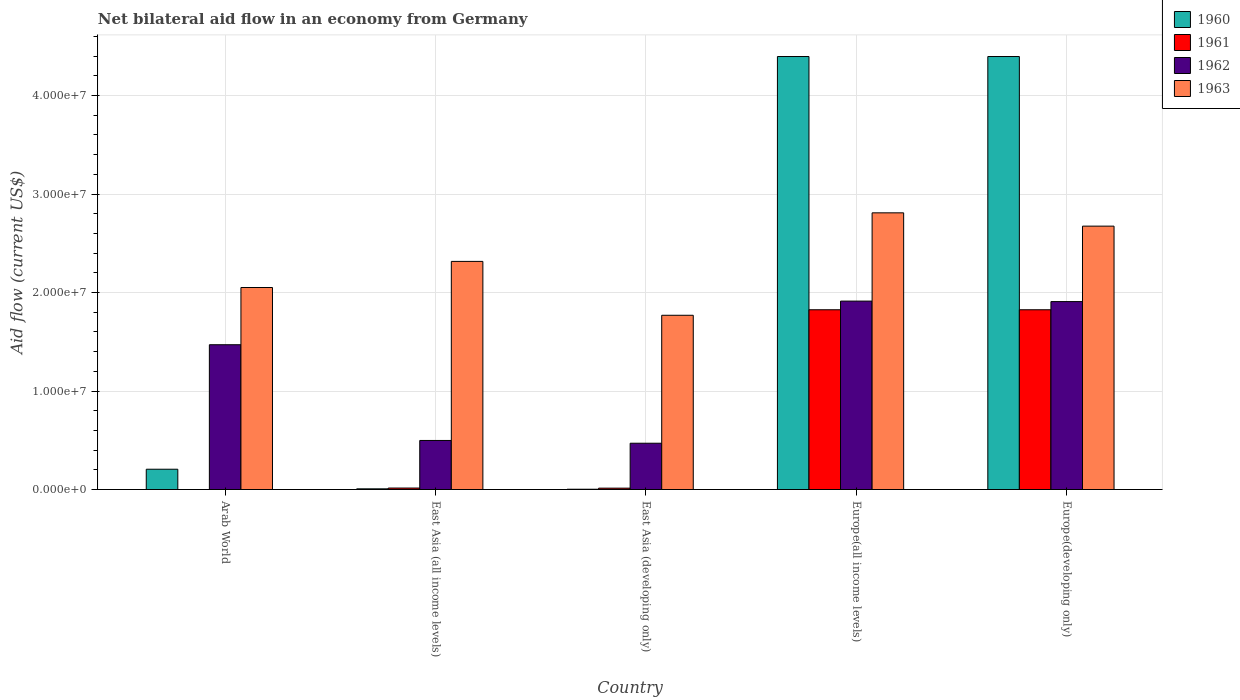Are the number of bars per tick equal to the number of legend labels?
Give a very brief answer. No. How many bars are there on the 3rd tick from the left?
Offer a terse response. 4. What is the label of the 1st group of bars from the left?
Keep it short and to the point. Arab World. In how many cases, is the number of bars for a given country not equal to the number of legend labels?
Your response must be concise. 1. What is the net bilateral aid flow in 1961 in Europe(developing only)?
Provide a succinct answer. 1.82e+07. Across all countries, what is the maximum net bilateral aid flow in 1960?
Your response must be concise. 4.40e+07. In which country was the net bilateral aid flow in 1960 maximum?
Ensure brevity in your answer.  Europe(all income levels). What is the total net bilateral aid flow in 1960 in the graph?
Your answer should be compact. 9.01e+07. What is the difference between the net bilateral aid flow in 1962 in East Asia (all income levels) and that in Europe(developing only)?
Make the answer very short. -1.41e+07. What is the difference between the net bilateral aid flow in 1963 in Arab World and the net bilateral aid flow in 1960 in Europe(all income levels)?
Your answer should be compact. -2.34e+07. What is the average net bilateral aid flow in 1960 per country?
Keep it short and to the point. 1.80e+07. What is the difference between the net bilateral aid flow of/in 1963 and net bilateral aid flow of/in 1962 in Europe(developing only)?
Make the answer very short. 7.66e+06. In how many countries, is the net bilateral aid flow in 1960 greater than 32000000 US$?
Give a very brief answer. 2. What is the ratio of the net bilateral aid flow in 1960 in Arab World to that in East Asia (developing only)?
Provide a short and direct response. 68.67. Is the net bilateral aid flow in 1960 in East Asia (developing only) less than that in Europe(developing only)?
Provide a succinct answer. Yes. What is the difference between the highest and the second highest net bilateral aid flow in 1960?
Offer a very short reply. 4.19e+07. What is the difference between the highest and the lowest net bilateral aid flow in 1962?
Provide a short and direct response. 1.44e+07. Is the sum of the net bilateral aid flow in 1960 in East Asia (developing only) and Europe(developing only) greater than the maximum net bilateral aid flow in 1961 across all countries?
Ensure brevity in your answer.  Yes. Is it the case that in every country, the sum of the net bilateral aid flow in 1962 and net bilateral aid flow in 1963 is greater than the sum of net bilateral aid flow in 1961 and net bilateral aid flow in 1960?
Your answer should be compact. No. How many bars are there?
Make the answer very short. 19. Are all the bars in the graph horizontal?
Give a very brief answer. No. Does the graph contain grids?
Ensure brevity in your answer.  Yes. How many legend labels are there?
Your answer should be compact. 4. How are the legend labels stacked?
Ensure brevity in your answer.  Vertical. What is the title of the graph?
Your answer should be compact. Net bilateral aid flow in an economy from Germany. What is the Aid flow (current US$) of 1960 in Arab World?
Keep it short and to the point. 2.06e+06. What is the Aid flow (current US$) of 1962 in Arab World?
Offer a very short reply. 1.47e+07. What is the Aid flow (current US$) of 1963 in Arab World?
Your answer should be very brief. 2.05e+07. What is the Aid flow (current US$) of 1961 in East Asia (all income levels)?
Ensure brevity in your answer.  1.50e+05. What is the Aid flow (current US$) in 1962 in East Asia (all income levels)?
Offer a terse response. 4.98e+06. What is the Aid flow (current US$) in 1963 in East Asia (all income levels)?
Offer a terse response. 2.32e+07. What is the Aid flow (current US$) of 1961 in East Asia (developing only)?
Provide a short and direct response. 1.40e+05. What is the Aid flow (current US$) of 1962 in East Asia (developing only)?
Your response must be concise. 4.70e+06. What is the Aid flow (current US$) in 1963 in East Asia (developing only)?
Provide a short and direct response. 1.77e+07. What is the Aid flow (current US$) of 1960 in Europe(all income levels)?
Your response must be concise. 4.40e+07. What is the Aid flow (current US$) of 1961 in Europe(all income levels)?
Ensure brevity in your answer.  1.82e+07. What is the Aid flow (current US$) in 1962 in Europe(all income levels)?
Give a very brief answer. 1.91e+07. What is the Aid flow (current US$) in 1963 in Europe(all income levels)?
Give a very brief answer. 2.81e+07. What is the Aid flow (current US$) of 1960 in Europe(developing only)?
Offer a very short reply. 4.40e+07. What is the Aid flow (current US$) in 1961 in Europe(developing only)?
Provide a short and direct response. 1.82e+07. What is the Aid flow (current US$) of 1962 in Europe(developing only)?
Your response must be concise. 1.91e+07. What is the Aid flow (current US$) of 1963 in Europe(developing only)?
Provide a short and direct response. 2.67e+07. Across all countries, what is the maximum Aid flow (current US$) of 1960?
Your answer should be compact. 4.40e+07. Across all countries, what is the maximum Aid flow (current US$) in 1961?
Provide a succinct answer. 1.82e+07. Across all countries, what is the maximum Aid flow (current US$) in 1962?
Your response must be concise. 1.91e+07. Across all countries, what is the maximum Aid flow (current US$) of 1963?
Your answer should be compact. 2.81e+07. Across all countries, what is the minimum Aid flow (current US$) in 1962?
Ensure brevity in your answer.  4.70e+06. Across all countries, what is the minimum Aid flow (current US$) in 1963?
Keep it short and to the point. 1.77e+07. What is the total Aid flow (current US$) in 1960 in the graph?
Provide a short and direct response. 9.01e+07. What is the total Aid flow (current US$) in 1961 in the graph?
Ensure brevity in your answer.  3.68e+07. What is the total Aid flow (current US$) of 1962 in the graph?
Your answer should be compact. 6.26e+07. What is the total Aid flow (current US$) of 1963 in the graph?
Offer a terse response. 1.16e+08. What is the difference between the Aid flow (current US$) in 1960 in Arab World and that in East Asia (all income levels)?
Your answer should be very brief. 1.99e+06. What is the difference between the Aid flow (current US$) of 1962 in Arab World and that in East Asia (all income levels)?
Your response must be concise. 9.72e+06. What is the difference between the Aid flow (current US$) in 1963 in Arab World and that in East Asia (all income levels)?
Keep it short and to the point. -2.65e+06. What is the difference between the Aid flow (current US$) in 1960 in Arab World and that in East Asia (developing only)?
Provide a short and direct response. 2.03e+06. What is the difference between the Aid flow (current US$) of 1962 in Arab World and that in East Asia (developing only)?
Provide a short and direct response. 1.00e+07. What is the difference between the Aid flow (current US$) in 1963 in Arab World and that in East Asia (developing only)?
Ensure brevity in your answer.  2.82e+06. What is the difference between the Aid flow (current US$) of 1960 in Arab World and that in Europe(all income levels)?
Provide a short and direct response. -4.19e+07. What is the difference between the Aid flow (current US$) in 1962 in Arab World and that in Europe(all income levels)?
Your answer should be very brief. -4.43e+06. What is the difference between the Aid flow (current US$) in 1963 in Arab World and that in Europe(all income levels)?
Offer a very short reply. -7.58e+06. What is the difference between the Aid flow (current US$) of 1960 in Arab World and that in Europe(developing only)?
Provide a succinct answer. -4.19e+07. What is the difference between the Aid flow (current US$) in 1962 in Arab World and that in Europe(developing only)?
Make the answer very short. -4.38e+06. What is the difference between the Aid flow (current US$) in 1963 in Arab World and that in Europe(developing only)?
Provide a succinct answer. -6.23e+06. What is the difference between the Aid flow (current US$) in 1960 in East Asia (all income levels) and that in East Asia (developing only)?
Your answer should be compact. 4.00e+04. What is the difference between the Aid flow (current US$) in 1961 in East Asia (all income levels) and that in East Asia (developing only)?
Ensure brevity in your answer.  10000. What is the difference between the Aid flow (current US$) of 1963 in East Asia (all income levels) and that in East Asia (developing only)?
Provide a short and direct response. 5.47e+06. What is the difference between the Aid flow (current US$) of 1960 in East Asia (all income levels) and that in Europe(all income levels)?
Keep it short and to the point. -4.39e+07. What is the difference between the Aid flow (current US$) of 1961 in East Asia (all income levels) and that in Europe(all income levels)?
Make the answer very short. -1.81e+07. What is the difference between the Aid flow (current US$) of 1962 in East Asia (all income levels) and that in Europe(all income levels)?
Your response must be concise. -1.42e+07. What is the difference between the Aid flow (current US$) of 1963 in East Asia (all income levels) and that in Europe(all income levels)?
Offer a very short reply. -4.93e+06. What is the difference between the Aid flow (current US$) of 1960 in East Asia (all income levels) and that in Europe(developing only)?
Give a very brief answer. -4.39e+07. What is the difference between the Aid flow (current US$) of 1961 in East Asia (all income levels) and that in Europe(developing only)?
Provide a short and direct response. -1.81e+07. What is the difference between the Aid flow (current US$) in 1962 in East Asia (all income levels) and that in Europe(developing only)?
Give a very brief answer. -1.41e+07. What is the difference between the Aid flow (current US$) of 1963 in East Asia (all income levels) and that in Europe(developing only)?
Offer a very short reply. -3.58e+06. What is the difference between the Aid flow (current US$) in 1960 in East Asia (developing only) and that in Europe(all income levels)?
Provide a short and direct response. -4.39e+07. What is the difference between the Aid flow (current US$) in 1961 in East Asia (developing only) and that in Europe(all income levels)?
Make the answer very short. -1.81e+07. What is the difference between the Aid flow (current US$) of 1962 in East Asia (developing only) and that in Europe(all income levels)?
Offer a terse response. -1.44e+07. What is the difference between the Aid flow (current US$) in 1963 in East Asia (developing only) and that in Europe(all income levels)?
Your response must be concise. -1.04e+07. What is the difference between the Aid flow (current US$) of 1960 in East Asia (developing only) and that in Europe(developing only)?
Your response must be concise. -4.39e+07. What is the difference between the Aid flow (current US$) of 1961 in East Asia (developing only) and that in Europe(developing only)?
Keep it short and to the point. -1.81e+07. What is the difference between the Aid flow (current US$) of 1962 in East Asia (developing only) and that in Europe(developing only)?
Your answer should be compact. -1.44e+07. What is the difference between the Aid flow (current US$) of 1963 in East Asia (developing only) and that in Europe(developing only)?
Give a very brief answer. -9.05e+06. What is the difference between the Aid flow (current US$) in 1960 in Europe(all income levels) and that in Europe(developing only)?
Offer a terse response. 0. What is the difference between the Aid flow (current US$) of 1961 in Europe(all income levels) and that in Europe(developing only)?
Provide a short and direct response. 0. What is the difference between the Aid flow (current US$) of 1963 in Europe(all income levels) and that in Europe(developing only)?
Provide a short and direct response. 1.35e+06. What is the difference between the Aid flow (current US$) in 1960 in Arab World and the Aid flow (current US$) in 1961 in East Asia (all income levels)?
Ensure brevity in your answer.  1.91e+06. What is the difference between the Aid flow (current US$) of 1960 in Arab World and the Aid flow (current US$) of 1962 in East Asia (all income levels)?
Your answer should be compact. -2.92e+06. What is the difference between the Aid flow (current US$) in 1960 in Arab World and the Aid flow (current US$) in 1963 in East Asia (all income levels)?
Offer a terse response. -2.11e+07. What is the difference between the Aid flow (current US$) of 1962 in Arab World and the Aid flow (current US$) of 1963 in East Asia (all income levels)?
Ensure brevity in your answer.  -8.46e+06. What is the difference between the Aid flow (current US$) of 1960 in Arab World and the Aid flow (current US$) of 1961 in East Asia (developing only)?
Offer a very short reply. 1.92e+06. What is the difference between the Aid flow (current US$) of 1960 in Arab World and the Aid flow (current US$) of 1962 in East Asia (developing only)?
Ensure brevity in your answer.  -2.64e+06. What is the difference between the Aid flow (current US$) of 1960 in Arab World and the Aid flow (current US$) of 1963 in East Asia (developing only)?
Your response must be concise. -1.56e+07. What is the difference between the Aid flow (current US$) of 1962 in Arab World and the Aid flow (current US$) of 1963 in East Asia (developing only)?
Offer a terse response. -2.99e+06. What is the difference between the Aid flow (current US$) of 1960 in Arab World and the Aid flow (current US$) of 1961 in Europe(all income levels)?
Provide a succinct answer. -1.62e+07. What is the difference between the Aid flow (current US$) of 1960 in Arab World and the Aid flow (current US$) of 1962 in Europe(all income levels)?
Your response must be concise. -1.71e+07. What is the difference between the Aid flow (current US$) of 1960 in Arab World and the Aid flow (current US$) of 1963 in Europe(all income levels)?
Provide a short and direct response. -2.60e+07. What is the difference between the Aid flow (current US$) in 1962 in Arab World and the Aid flow (current US$) in 1963 in Europe(all income levels)?
Your answer should be very brief. -1.34e+07. What is the difference between the Aid flow (current US$) in 1960 in Arab World and the Aid flow (current US$) in 1961 in Europe(developing only)?
Make the answer very short. -1.62e+07. What is the difference between the Aid flow (current US$) in 1960 in Arab World and the Aid flow (current US$) in 1962 in Europe(developing only)?
Offer a very short reply. -1.70e+07. What is the difference between the Aid flow (current US$) in 1960 in Arab World and the Aid flow (current US$) in 1963 in Europe(developing only)?
Ensure brevity in your answer.  -2.47e+07. What is the difference between the Aid flow (current US$) of 1962 in Arab World and the Aid flow (current US$) of 1963 in Europe(developing only)?
Offer a terse response. -1.20e+07. What is the difference between the Aid flow (current US$) in 1960 in East Asia (all income levels) and the Aid flow (current US$) in 1962 in East Asia (developing only)?
Provide a short and direct response. -4.63e+06. What is the difference between the Aid flow (current US$) in 1960 in East Asia (all income levels) and the Aid flow (current US$) in 1963 in East Asia (developing only)?
Keep it short and to the point. -1.76e+07. What is the difference between the Aid flow (current US$) of 1961 in East Asia (all income levels) and the Aid flow (current US$) of 1962 in East Asia (developing only)?
Give a very brief answer. -4.55e+06. What is the difference between the Aid flow (current US$) of 1961 in East Asia (all income levels) and the Aid flow (current US$) of 1963 in East Asia (developing only)?
Make the answer very short. -1.75e+07. What is the difference between the Aid flow (current US$) in 1962 in East Asia (all income levels) and the Aid flow (current US$) in 1963 in East Asia (developing only)?
Your answer should be very brief. -1.27e+07. What is the difference between the Aid flow (current US$) of 1960 in East Asia (all income levels) and the Aid flow (current US$) of 1961 in Europe(all income levels)?
Your answer should be very brief. -1.82e+07. What is the difference between the Aid flow (current US$) of 1960 in East Asia (all income levels) and the Aid flow (current US$) of 1962 in Europe(all income levels)?
Provide a succinct answer. -1.91e+07. What is the difference between the Aid flow (current US$) in 1960 in East Asia (all income levels) and the Aid flow (current US$) in 1963 in Europe(all income levels)?
Ensure brevity in your answer.  -2.80e+07. What is the difference between the Aid flow (current US$) in 1961 in East Asia (all income levels) and the Aid flow (current US$) in 1962 in Europe(all income levels)?
Offer a very short reply. -1.90e+07. What is the difference between the Aid flow (current US$) of 1961 in East Asia (all income levels) and the Aid flow (current US$) of 1963 in Europe(all income levels)?
Ensure brevity in your answer.  -2.79e+07. What is the difference between the Aid flow (current US$) of 1962 in East Asia (all income levels) and the Aid flow (current US$) of 1963 in Europe(all income levels)?
Keep it short and to the point. -2.31e+07. What is the difference between the Aid flow (current US$) of 1960 in East Asia (all income levels) and the Aid flow (current US$) of 1961 in Europe(developing only)?
Give a very brief answer. -1.82e+07. What is the difference between the Aid flow (current US$) in 1960 in East Asia (all income levels) and the Aid flow (current US$) in 1962 in Europe(developing only)?
Ensure brevity in your answer.  -1.90e+07. What is the difference between the Aid flow (current US$) in 1960 in East Asia (all income levels) and the Aid flow (current US$) in 1963 in Europe(developing only)?
Make the answer very short. -2.67e+07. What is the difference between the Aid flow (current US$) of 1961 in East Asia (all income levels) and the Aid flow (current US$) of 1962 in Europe(developing only)?
Give a very brief answer. -1.89e+07. What is the difference between the Aid flow (current US$) of 1961 in East Asia (all income levels) and the Aid flow (current US$) of 1963 in Europe(developing only)?
Your answer should be compact. -2.66e+07. What is the difference between the Aid flow (current US$) of 1962 in East Asia (all income levels) and the Aid flow (current US$) of 1963 in Europe(developing only)?
Give a very brief answer. -2.18e+07. What is the difference between the Aid flow (current US$) of 1960 in East Asia (developing only) and the Aid flow (current US$) of 1961 in Europe(all income levels)?
Your answer should be compact. -1.82e+07. What is the difference between the Aid flow (current US$) in 1960 in East Asia (developing only) and the Aid flow (current US$) in 1962 in Europe(all income levels)?
Your answer should be very brief. -1.91e+07. What is the difference between the Aid flow (current US$) in 1960 in East Asia (developing only) and the Aid flow (current US$) in 1963 in Europe(all income levels)?
Keep it short and to the point. -2.81e+07. What is the difference between the Aid flow (current US$) in 1961 in East Asia (developing only) and the Aid flow (current US$) in 1962 in Europe(all income levels)?
Your answer should be compact. -1.90e+07. What is the difference between the Aid flow (current US$) in 1961 in East Asia (developing only) and the Aid flow (current US$) in 1963 in Europe(all income levels)?
Keep it short and to the point. -2.80e+07. What is the difference between the Aid flow (current US$) in 1962 in East Asia (developing only) and the Aid flow (current US$) in 1963 in Europe(all income levels)?
Your response must be concise. -2.34e+07. What is the difference between the Aid flow (current US$) in 1960 in East Asia (developing only) and the Aid flow (current US$) in 1961 in Europe(developing only)?
Your answer should be very brief. -1.82e+07. What is the difference between the Aid flow (current US$) of 1960 in East Asia (developing only) and the Aid flow (current US$) of 1962 in Europe(developing only)?
Ensure brevity in your answer.  -1.90e+07. What is the difference between the Aid flow (current US$) in 1960 in East Asia (developing only) and the Aid flow (current US$) in 1963 in Europe(developing only)?
Offer a terse response. -2.67e+07. What is the difference between the Aid flow (current US$) of 1961 in East Asia (developing only) and the Aid flow (current US$) of 1962 in Europe(developing only)?
Provide a succinct answer. -1.89e+07. What is the difference between the Aid flow (current US$) in 1961 in East Asia (developing only) and the Aid flow (current US$) in 1963 in Europe(developing only)?
Ensure brevity in your answer.  -2.66e+07. What is the difference between the Aid flow (current US$) of 1962 in East Asia (developing only) and the Aid flow (current US$) of 1963 in Europe(developing only)?
Provide a short and direct response. -2.20e+07. What is the difference between the Aid flow (current US$) in 1960 in Europe(all income levels) and the Aid flow (current US$) in 1961 in Europe(developing only)?
Provide a short and direct response. 2.57e+07. What is the difference between the Aid flow (current US$) of 1960 in Europe(all income levels) and the Aid flow (current US$) of 1962 in Europe(developing only)?
Ensure brevity in your answer.  2.49e+07. What is the difference between the Aid flow (current US$) of 1960 in Europe(all income levels) and the Aid flow (current US$) of 1963 in Europe(developing only)?
Your response must be concise. 1.72e+07. What is the difference between the Aid flow (current US$) in 1961 in Europe(all income levels) and the Aid flow (current US$) in 1962 in Europe(developing only)?
Give a very brief answer. -8.30e+05. What is the difference between the Aid flow (current US$) in 1961 in Europe(all income levels) and the Aid flow (current US$) in 1963 in Europe(developing only)?
Provide a short and direct response. -8.49e+06. What is the difference between the Aid flow (current US$) of 1962 in Europe(all income levels) and the Aid flow (current US$) of 1963 in Europe(developing only)?
Your answer should be very brief. -7.61e+06. What is the average Aid flow (current US$) of 1960 per country?
Provide a succinct answer. 1.80e+07. What is the average Aid flow (current US$) in 1961 per country?
Offer a terse response. 7.36e+06. What is the average Aid flow (current US$) in 1962 per country?
Offer a very short reply. 1.25e+07. What is the average Aid flow (current US$) of 1963 per country?
Ensure brevity in your answer.  2.32e+07. What is the difference between the Aid flow (current US$) of 1960 and Aid flow (current US$) of 1962 in Arab World?
Your response must be concise. -1.26e+07. What is the difference between the Aid flow (current US$) of 1960 and Aid flow (current US$) of 1963 in Arab World?
Provide a short and direct response. -1.84e+07. What is the difference between the Aid flow (current US$) in 1962 and Aid flow (current US$) in 1963 in Arab World?
Your answer should be compact. -5.81e+06. What is the difference between the Aid flow (current US$) of 1960 and Aid flow (current US$) of 1961 in East Asia (all income levels)?
Provide a succinct answer. -8.00e+04. What is the difference between the Aid flow (current US$) in 1960 and Aid flow (current US$) in 1962 in East Asia (all income levels)?
Make the answer very short. -4.91e+06. What is the difference between the Aid flow (current US$) of 1960 and Aid flow (current US$) of 1963 in East Asia (all income levels)?
Make the answer very short. -2.31e+07. What is the difference between the Aid flow (current US$) of 1961 and Aid flow (current US$) of 1962 in East Asia (all income levels)?
Your answer should be very brief. -4.83e+06. What is the difference between the Aid flow (current US$) of 1961 and Aid flow (current US$) of 1963 in East Asia (all income levels)?
Provide a succinct answer. -2.30e+07. What is the difference between the Aid flow (current US$) in 1962 and Aid flow (current US$) in 1963 in East Asia (all income levels)?
Give a very brief answer. -1.82e+07. What is the difference between the Aid flow (current US$) in 1960 and Aid flow (current US$) in 1962 in East Asia (developing only)?
Keep it short and to the point. -4.67e+06. What is the difference between the Aid flow (current US$) of 1960 and Aid flow (current US$) of 1963 in East Asia (developing only)?
Ensure brevity in your answer.  -1.77e+07. What is the difference between the Aid flow (current US$) of 1961 and Aid flow (current US$) of 1962 in East Asia (developing only)?
Your response must be concise. -4.56e+06. What is the difference between the Aid flow (current US$) in 1961 and Aid flow (current US$) in 1963 in East Asia (developing only)?
Offer a terse response. -1.76e+07. What is the difference between the Aid flow (current US$) of 1962 and Aid flow (current US$) of 1963 in East Asia (developing only)?
Offer a terse response. -1.30e+07. What is the difference between the Aid flow (current US$) of 1960 and Aid flow (current US$) of 1961 in Europe(all income levels)?
Your response must be concise. 2.57e+07. What is the difference between the Aid flow (current US$) in 1960 and Aid flow (current US$) in 1962 in Europe(all income levels)?
Your answer should be compact. 2.48e+07. What is the difference between the Aid flow (current US$) in 1960 and Aid flow (current US$) in 1963 in Europe(all income levels)?
Make the answer very short. 1.59e+07. What is the difference between the Aid flow (current US$) of 1961 and Aid flow (current US$) of 1962 in Europe(all income levels)?
Ensure brevity in your answer.  -8.80e+05. What is the difference between the Aid flow (current US$) in 1961 and Aid flow (current US$) in 1963 in Europe(all income levels)?
Your answer should be very brief. -9.84e+06. What is the difference between the Aid flow (current US$) in 1962 and Aid flow (current US$) in 1963 in Europe(all income levels)?
Keep it short and to the point. -8.96e+06. What is the difference between the Aid flow (current US$) in 1960 and Aid flow (current US$) in 1961 in Europe(developing only)?
Keep it short and to the point. 2.57e+07. What is the difference between the Aid flow (current US$) of 1960 and Aid flow (current US$) of 1962 in Europe(developing only)?
Your answer should be compact. 2.49e+07. What is the difference between the Aid flow (current US$) of 1960 and Aid flow (current US$) of 1963 in Europe(developing only)?
Offer a terse response. 1.72e+07. What is the difference between the Aid flow (current US$) of 1961 and Aid flow (current US$) of 1962 in Europe(developing only)?
Ensure brevity in your answer.  -8.30e+05. What is the difference between the Aid flow (current US$) in 1961 and Aid flow (current US$) in 1963 in Europe(developing only)?
Make the answer very short. -8.49e+06. What is the difference between the Aid flow (current US$) in 1962 and Aid flow (current US$) in 1963 in Europe(developing only)?
Provide a short and direct response. -7.66e+06. What is the ratio of the Aid flow (current US$) in 1960 in Arab World to that in East Asia (all income levels)?
Ensure brevity in your answer.  29.43. What is the ratio of the Aid flow (current US$) in 1962 in Arab World to that in East Asia (all income levels)?
Your answer should be compact. 2.95. What is the ratio of the Aid flow (current US$) of 1963 in Arab World to that in East Asia (all income levels)?
Provide a short and direct response. 0.89. What is the ratio of the Aid flow (current US$) in 1960 in Arab World to that in East Asia (developing only)?
Offer a terse response. 68.67. What is the ratio of the Aid flow (current US$) of 1962 in Arab World to that in East Asia (developing only)?
Provide a succinct answer. 3.13. What is the ratio of the Aid flow (current US$) in 1963 in Arab World to that in East Asia (developing only)?
Your answer should be compact. 1.16. What is the ratio of the Aid flow (current US$) of 1960 in Arab World to that in Europe(all income levels)?
Your answer should be compact. 0.05. What is the ratio of the Aid flow (current US$) of 1962 in Arab World to that in Europe(all income levels)?
Provide a short and direct response. 0.77. What is the ratio of the Aid flow (current US$) in 1963 in Arab World to that in Europe(all income levels)?
Keep it short and to the point. 0.73. What is the ratio of the Aid flow (current US$) in 1960 in Arab World to that in Europe(developing only)?
Your answer should be very brief. 0.05. What is the ratio of the Aid flow (current US$) in 1962 in Arab World to that in Europe(developing only)?
Give a very brief answer. 0.77. What is the ratio of the Aid flow (current US$) in 1963 in Arab World to that in Europe(developing only)?
Make the answer very short. 0.77. What is the ratio of the Aid flow (current US$) in 1960 in East Asia (all income levels) to that in East Asia (developing only)?
Your answer should be compact. 2.33. What is the ratio of the Aid flow (current US$) in 1961 in East Asia (all income levels) to that in East Asia (developing only)?
Ensure brevity in your answer.  1.07. What is the ratio of the Aid flow (current US$) in 1962 in East Asia (all income levels) to that in East Asia (developing only)?
Make the answer very short. 1.06. What is the ratio of the Aid flow (current US$) in 1963 in East Asia (all income levels) to that in East Asia (developing only)?
Provide a succinct answer. 1.31. What is the ratio of the Aid flow (current US$) of 1960 in East Asia (all income levels) to that in Europe(all income levels)?
Give a very brief answer. 0. What is the ratio of the Aid flow (current US$) of 1961 in East Asia (all income levels) to that in Europe(all income levels)?
Keep it short and to the point. 0.01. What is the ratio of the Aid flow (current US$) in 1962 in East Asia (all income levels) to that in Europe(all income levels)?
Keep it short and to the point. 0.26. What is the ratio of the Aid flow (current US$) of 1963 in East Asia (all income levels) to that in Europe(all income levels)?
Make the answer very short. 0.82. What is the ratio of the Aid flow (current US$) of 1960 in East Asia (all income levels) to that in Europe(developing only)?
Provide a short and direct response. 0. What is the ratio of the Aid flow (current US$) of 1961 in East Asia (all income levels) to that in Europe(developing only)?
Your answer should be very brief. 0.01. What is the ratio of the Aid flow (current US$) in 1962 in East Asia (all income levels) to that in Europe(developing only)?
Offer a terse response. 0.26. What is the ratio of the Aid flow (current US$) of 1963 in East Asia (all income levels) to that in Europe(developing only)?
Provide a short and direct response. 0.87. What is the ratio of the Aid flow (current US$) of 1960 in East Asia (developing only) to that in Europe(all income levels)?
Provide a short and direct response. 0. What is the ratio of the Aid flow (current US$) in 1961 in East Asia (developing only) to that in Europe(all income levels)?
Give a very brief answer. 0.01. What is the ratio of the Aid flow (current US$) in 1962 in East Asia (developing only) to that in Europe(all income levels)?
Provide a short and direct response. 0.25. What is the ratio of the Aid flow (current US$) in 1963 in East Asia (developing only) to that in Europe(all income levels)?
Your response must be concise. 0.63. What is the ratio of the Aid flow (current US$) in 1960 in East Asia (developing only) to that in Europe(developing only)?
Offer a terse response. 0. What is the ratio of the Aid flow (current US$) of 1961 in East Asia (developing only) to that in Europe(developing only)?
Your answer should be very brief. 0.01. What is the ratio of the Aid flow (current US$) of 1962 in East Asia (developing only) to that in Europe(developing only)?
Your response must be concise. 0.25. What is the ratio of the Aid flow (current US$) in 1963 in East Asia (developing only) to that in Europe(developing only)?
Ensure brevity in your answer.  0.66. What is the ratio of the Aid flow (current US$) in 1962 in Europe(all income levels) to that in Europe(developing only)?
Offer a very short reply. 1. What is the ratio of the Aid flow (current US$) in 1963 in Europe(all income levels) to that in Europe(developing only)?
Offer a terse response. 1.05. What is the difference between the highest and the second highest Aid flow (current US$) in 1961?
Ensure brevity in your answer.  0. What is the difference between the highest and the second highest Aid flow (current US$) of 1963?
Offer a terse response. 1.35e+06. What is the difference between the highest and the lowest Aid flow (current US$) in 1960?
Offer a very short reply. 4.39e+07. What is the difference between the highest and the lowest Aid flow (current US$) of 1961?
Offer a very short reply. 1.82e+07. What is the difference between the highest and the lowest Aid flow (current US$) in 1962?
Provide a succinct answer. 1.44e+07. What is the difference between the highest and the lowest Aid flow (current US$) in 1963?
Your answer should be compact. 1.04e+07. 